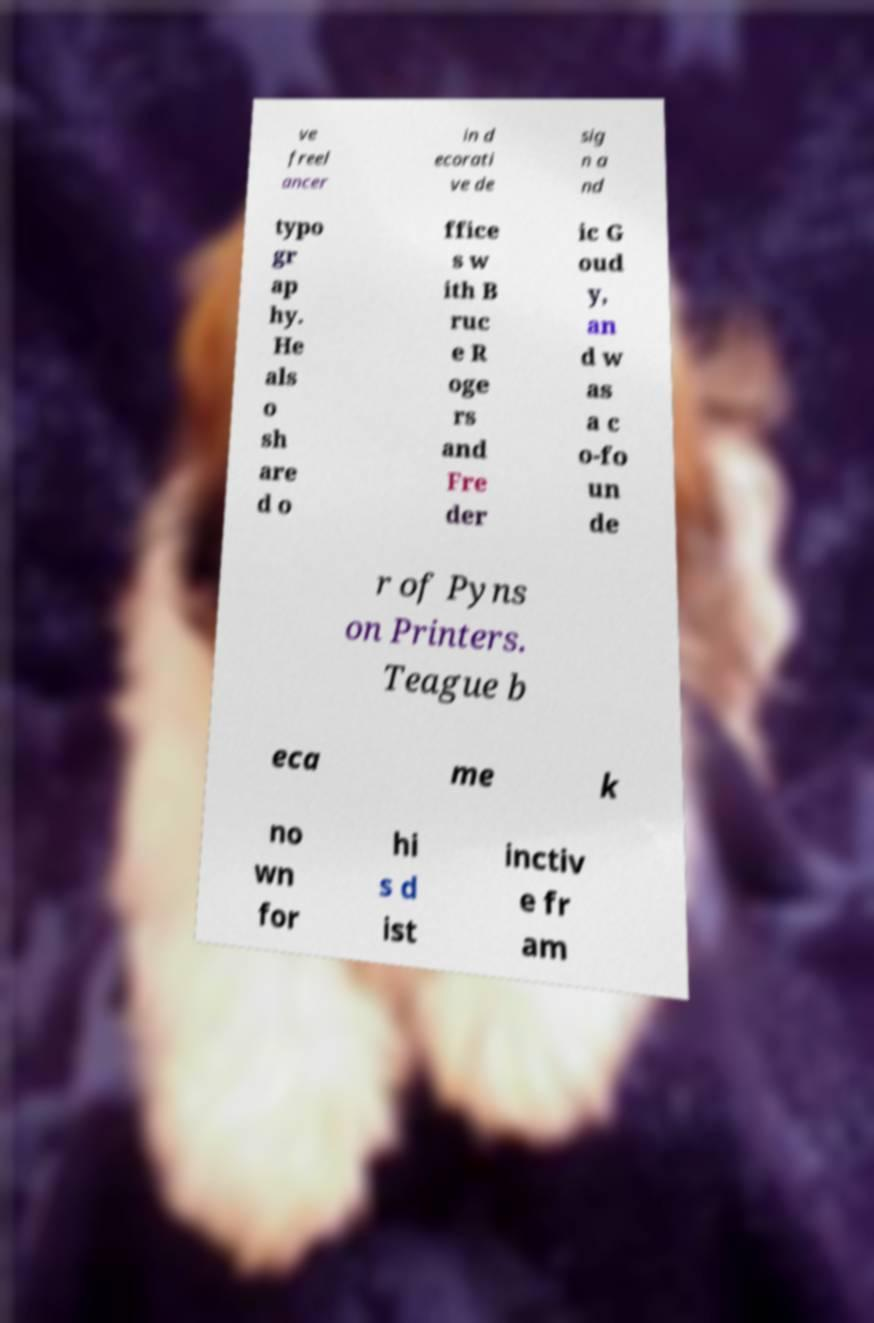Could you assist in decoding the text presented in this image and type it out clearly? ve freel ancer in d ecorati ve de sig n a nd typo gr ap hy. He als o sh are d o ffice s w ith B ruc e R oge rs and Fre der ic G oud y, an d w as a c o-fo un de r of Pyns on Printers. Teague b eca me k no wn for hi s d ist inctiv e fr am 